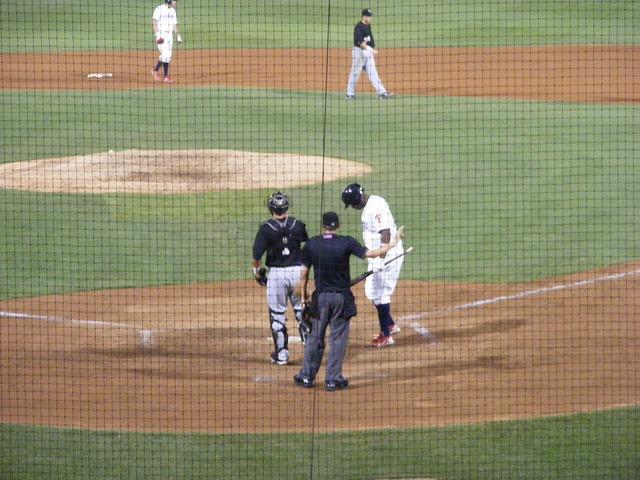How many people are in the photo?
Give a very brief answer. 3. 